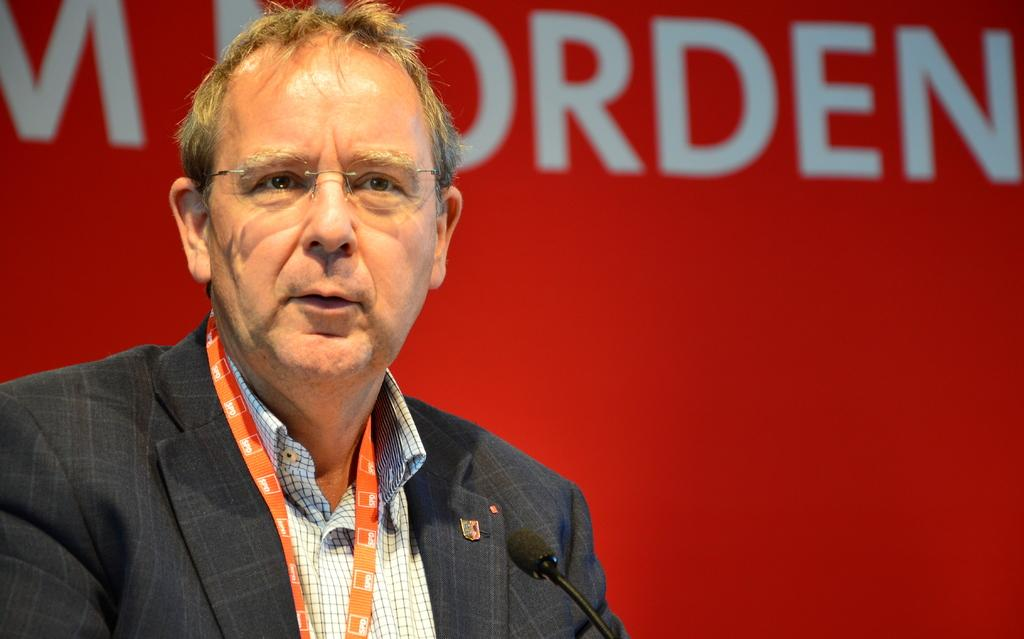What is the main subject of the image? There is a person in the image. What is the person wearing? The person is wearing a black blazer and a white shirt. What object can be seen near the person? There is a microphone in the image. What colors are present in the background of the image? The background of the image has red and white colors. Can you hear the person whistling in the image? There is no indication of whistling in the image, as it only shows a person wearing a black blazer and white shirt, with a microphone nearby. What type of reward is the person receiving in the image? There is no reward being given in the image; it only shows a person with a microphone and specific clothing. 